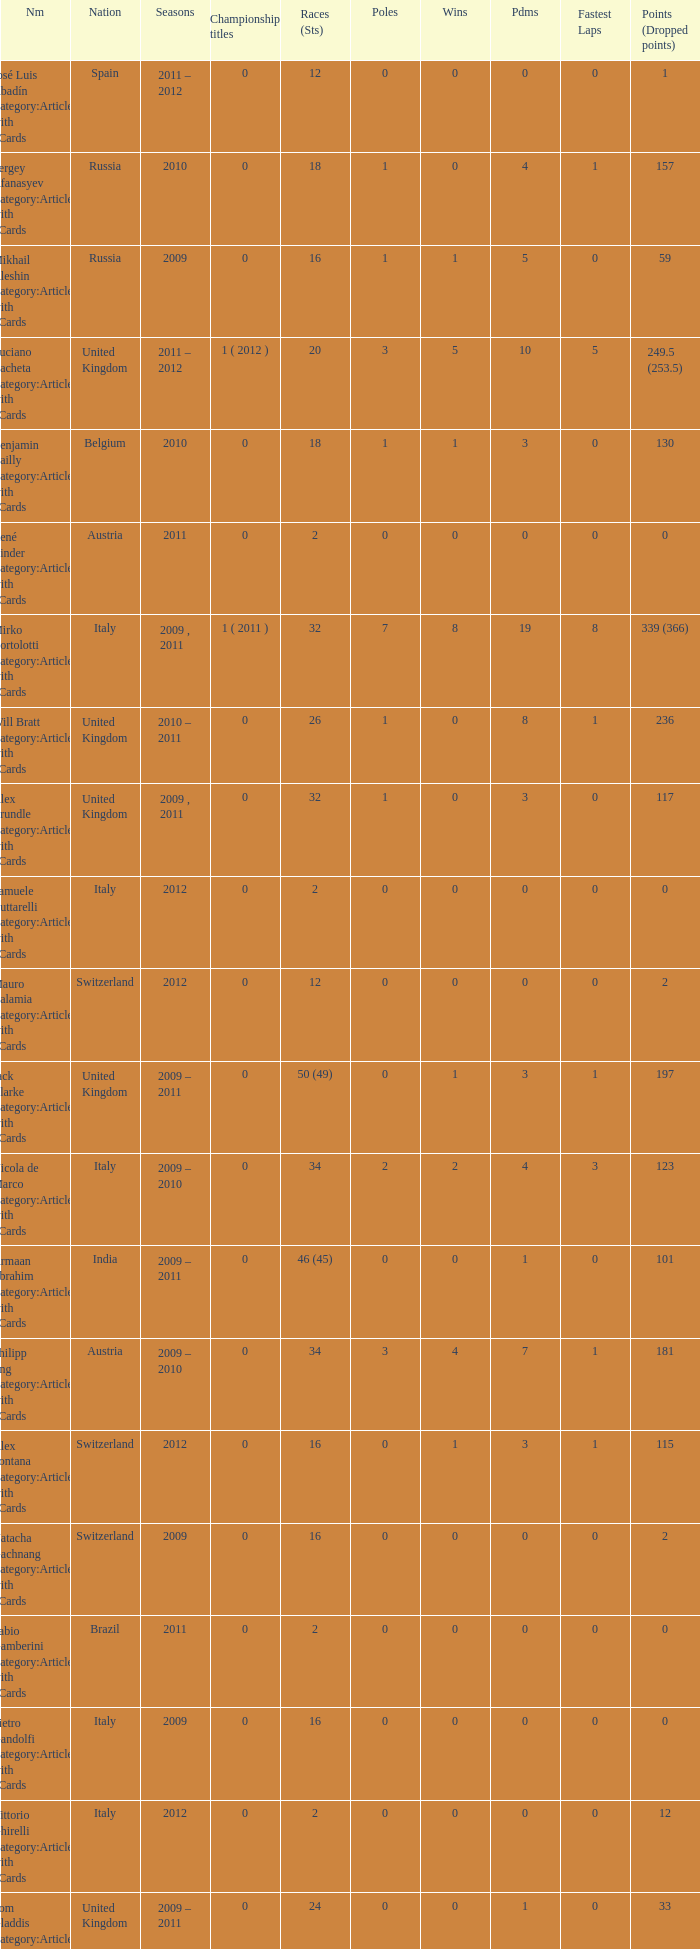Would you be able to parse every entry in this table? {'header': ['Nm', 'Nation', 'Seasons', 'Championship titles', 'Races (Sts)', 'Poles', 'Wins', 'Pdms', 'Fastest Laps', 'Points (Dropped points)'], 'rows': [['José Luis Abadín Category:Articles with hCards', 'Spain', '2011 – 2012', '0', '12', '0', '0', '0', '0', '1'], ['Sergey Afanasyev Category:Articles with hCards', 'Russia', '2010', '0', '18', '1', '0', '4', '1', '157'], ['Mikhail Aleshin Category:Articles with hCards', 'Russia', '2009', '0', '16', '1', '1', '5', '0', '59'], ['Luciano Bacheta Category:Articles with hCards', 'United Kingdom', '2011 – 2012', '1 ( 2012 )', '20', '3', '5', '10', '5', '249.5 (253.5)'], ['Benjamin Bailly Category:Articles with hCards', 'Belgium', '2010', '0', '18', '1', '1', '3', '0', '130'], ['René Binder Category:Articles with hCards', 'Austria', '2011', '0', '2', '0', '0', '0', '0', '0'], ['Mirko Bortolotti Category:Articles with hCards', 'Italy', '2009 , 2011', '1 ( 2011 )', '32', '7', '8', '19', '8', '339 (366)'], ['Will Bratt Category:Articles with hCards', 'United Kingdom', '2010 – 2011', '0', '26', '1', '0', '8', '1', '236'], ['Alex Brundle Category:Articles with hCards', 'United Kingdom', '2009 , 2011', '0', '32', '1', '0', '3', '0', '117'], ['Samuele Buttarelli Category:Articles with hCards', 'Italy', '2012', '0', '2', '0', '0', '0', '0', '0'], ['Mauro Calamia Category:Articles with hCards', 'Switzerland', '2012', '0', '12', '0', '0', '0', '0', '2'], ['Jack Clarke Category:Articles with hCards', 'United Kingdom', '2009 – 2011', '0', '50 (49)', '0', '1', '3', '1', '197'], ['Nicola de Marco Category:Articles with hCards', 'Italy', '2009 – 2010', '0', '34', '2', '2', '4', '3', '123'], ['Armaan Ebrahim Category:Articles with hCards', 'India', '2009 – 2011', '0', '46 (45)', '0', '0', '1', '0', '101'], ['Philipp Eng Category:Articles with hCards', 'Austria', '2009 – 2010', '0', '34', '3', '4', '7', '1', '181'], ['Alex Fontana Category:Articles with hCards', 'Switzerland', '2012', '0', '16', '0', '1', '3', '1', '115'], ['Natacha Gachnang Category:Articles with hCards', 'Switzerland', '2009', '0', '16', '0', '0', '0', '0', '2'], ['Fabio Gamberini Category:Articles with hCards', 'Brazil', '2011', '0', '2', '0', '0', '0', '0', '0'], ['Pietro Gandolfi Category:Articles with hCards', 'Italy', '2009', '0', '16', '0', '0', '0', '0', '0'], ['Vittorio Ghirelli Category:Articles with hCards', 'Italy', '2012', '0', '2', '0', '0', '0', '0', '12'], ['Tom Gladdis Category:Articles with hCards', 'United Kingdom', '2009 – 2011', '0', '24', '0', '0', '1', '0', '33'], ['Richard Gonda Category:Articles with hCards', 'Slovakia', '2012', '0', '2', '0', '0', '0', '0', '4'], ['Victor Guerin Category:Articles with hCards', 'Brazil', '2012', '0', '2', '0', '0', '0', '0', '2'], ['Ollie Hancock Category:Articles with hCards', 'United Kingdom', '2009', '0', '6', '0', '0', '0', '0', '0'], ['Tobias Hegewald Category:Articles with hCards', 'Germany', '2009 , 2011', '0', '32', '4', '2', '5', '3', '158'], ['Sebastian Hohenthal Category:Articles with hCards', 'Sweden', '2009', '0', '16', '0', '0', '0', '0', '7'], ['Jens Höing Category:Articles with hCards', 'Germany', '2009', '0', '16', '0', '0', '0', '0', '0'], ['Hector Hurst Category:Articles with hCards', 'United Kingdom', '2012', '0', '16', '0', '0', '0', '0', '27'], ['Carlos Iaconelli Category:Articles with hCards', 'Brazil', '2009', '0', '14', '0', '0', '1', '0', '21'], ['Axcil Jefferies Category:Articles with hCards', 'Zimbabwe', '2012', '0', '12 (11)', '0', '0', '0', '0', '17'], ['Johan Jokinen Category:Articles with hCards', 'Denmark', '2010', '0', '6', '0', '0', '1', '1', '21'], ['Julien Jousse Category:Articles with hCards', 'France', '2009', '0', '16', '1', '1', '4', '2', '49'], ['Henri Karjalainen Category:Articles with hCards', 'Finland', '2009', '0', '16', '0', '0', '0', '0', '7'], ['Kourosh Khani Category:Articles with hCards', 'Iran', '2012', '0', '8', '0', '0', '0', '0', '2'], ['Jordan King Category:Articles with hCards', 'United Kingdom', '2011', '0', '6', '0', '0', '0', '0', '17'], ['Natalia Kowalska Category:Articles with hCards', 'Poland', '2010 – 2011', '0', '20', '0', '0', '0', '0', '3'], ['Plamen Kralev Category:Articles with hCards', 'Bulgaria', '2010 – 2012', '0', '50 (49)', '0', '0', '0', '0', '6'], ['Ajith Kumar Category:Articles with hCards', 'India', '2010', '0', '6', '0', '0', '0', '0', '0'], ['Jon Lancaster Category:Articles with hCards', 'United Kingdom', '2011', '0', '2', '0', '0', '0', '0', '14'], ['Benjamin Lariche Category:Articles with hCards', 'France', '2010 – 2011', '0', '34', '0', '0', '0', '0', '48'], ['Mikkel Mac Category:Articles with hCards', 'Denmark', '2011', '0', '16', '0', '0', '0', '0', '23'], ['Mihai Marinescu Category:Articles with hCards', 'Romania', '2010 – 2012', '0', '50', '4', '3', '8', '4', '299'], ['Daniel McKenzie Category:Articles with hCards', 'United Kingdom', '2012', '0', '16', '0', '0', '2', '0', '95'], ['Kevin Mirocha Category:Articles with hCards', 'Poland', '2012', '0', '16', '1', '1', '6', '0', '159.5'], ['Miki Monrás Category:Articles with hCards', 'Spain', '2011', '0', '16', '1', '1', '4', '1', '153'], ['Jason Moore Category:Articles with hCards', 'United Kingdom', '2009', '0', '16 (15)', '0', '0', '0', '0', '3'], ['Sung-Hak Mun Category:Articles with hCards', 'South Korea', '2011', '0', '16 (15)', '0', '0', '0', '0', '0'], ['Jolyon Palmer Category:Articles with hCards', 'United Kingdom', '2009 – 2010', '0', '34 (36)', '5', '5', '10', '3', '245'], ['Miloš Pavlović Category:Articles with hCards', 'Serbia', '2009', '0', '16', '0', '0', '2', '1', '29'], ['Ramón Piñeiro Category:Articles with hCards', 'Spain', '2010 – 2011', '0', '18', '2', '3', '7', '2', '186'], ['Markus Pommer Category:Articles with hCards', 'Germany', '2012', '0', '16', '4', '3', '5', '2', '169'], ['Edoardo Piscopo Category:Articles with hCards', 'Italy', '2009', '0', '14', '0', '0', '0', '0', '19'], ['Paul Rees Category:Articles with hCards', 'United Kingdom', '2010', '0', '8', '0', '0', '0', '0', '18'], ['Ivan Samarin Category:Articles with hCards', 'Russia', '2010', '0', '18', '0', '0', '0', '0', '64'], ['Germán Sánchez Category:Articles with hCards', 'Spain', '2009', '0', '16 (14)', '0', '0', '0', '0', '2'], ['Harald Schlegelmilch Category:Articles with hCards', 'Latvia', '2012', '0', '2', '0', '0', '0', '0', '12'], ['Max Snegirev Category:Articles with hCards', 'Russia', '2011 – 2012', '0', '28', '0', '0', '0', '0', '20'], ['Kelvin Snoeks Category:Articles with hCards', 'Netherlands', '2010 – 2011', '0', '32', '0', '0', '1', '0', '88'], ['Andy Soucek Category:Articles with hCards', 'Spain', '2009', '1 ( 2009 )', '16', '2', '7', '11', '3', '115'], ['Dean Stoneman Category:Articles with hCards', 'United Kingdom', '2010', '1 ( 2010 )', '18', '6', '6', '13', '6', '284'], ['Thiemo Storz Category:Articles with hCards', 'Germany', '2011', '0', '16', '0', '0', '0', '0', '19'], ['Parthiva Sureshwaren Category:Articles with hCards', 'India', '2010 – 2012', '0', '32 (31)', '0', '0', '0', '0', '1'], ['Henry Surtees Category:Articles with hCards', 'United Kingdom', '2009', '0', '8', '1', '0', '1', '0', '8'], ['Ricardo Teixeira Category:Articles with hCards', 'Angola', '2010', '0', '18', '0', '0', '0', '0', '23'], ['Johannes Theobald Category:Articles with hCards', 'Germany', '2010 – 2011', '0', '14', '0', '0', '0', '0', '1'], ['Julian Theobald Category:Articles with hCards', 'Germany', '2010 – 2011', '0', '18', '0', '0', '0', '0', '8'], ['Mathéo Tuscher Category:Articles with hCards', 'Switzerland', '2012', '0', '16', '4', '2', '9', '1', '210'], ['Tristan Vautier Category:Articles with hCards', 'France', '2009', '0', '2', '0', '0', '1', '0', '9'], ['Kazim Vasiliauskas Category:Articles with hCards', 'Lithuania', '2009 – 2010', '0', '34', '3', '2', '10', '4', '198'], ['Robert Wickens Category:Articles with hCards', 'Canada', '2009', '0', '16', '5', '2', '6', '3', '64'], ['Dino Zamparelli Category:Articles with hCards', 'United Kingdom', '2012', '0', '16', '0', '0', '2', '0', '106.5'], ['Christopher Zanella Category:Articles with hCards', 'Switzerland', '2011 – 2012', '0', '32', '3', '4', '14', '5', '385 (401)']]} When did they win 7 races? 2009.0. 